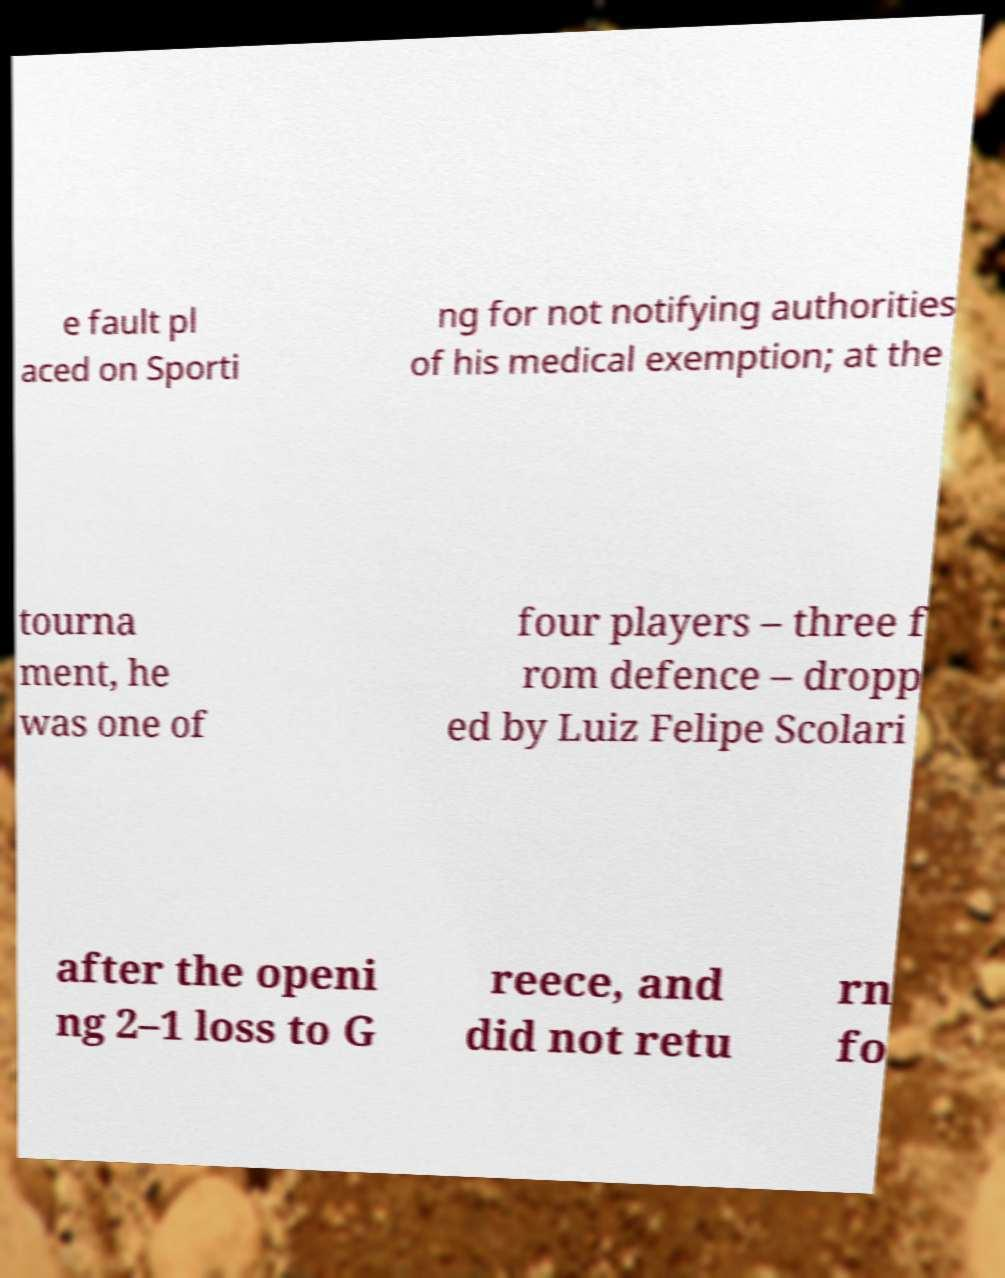Could you assist in decoding the text presented in this image and type it out clearly? e fault pl aced on Sporti ng for not notifying authorities of his medical exemption; at the tourna ment, he was one of four players – three f rom defence – dropp ed by Luiz Felipe Scolari after the openi ng 2–1 loss to G reece, and did not retu rn fo 